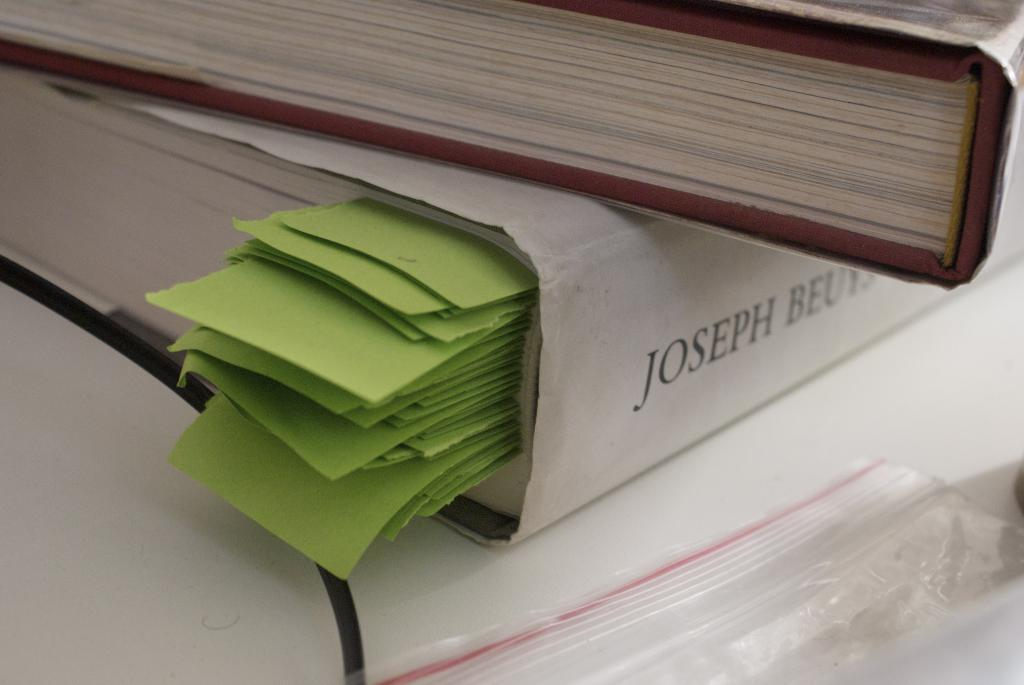<image>
Give a short and clear explanation of the subsequent image. A white book features the word Joseph on the spine. 